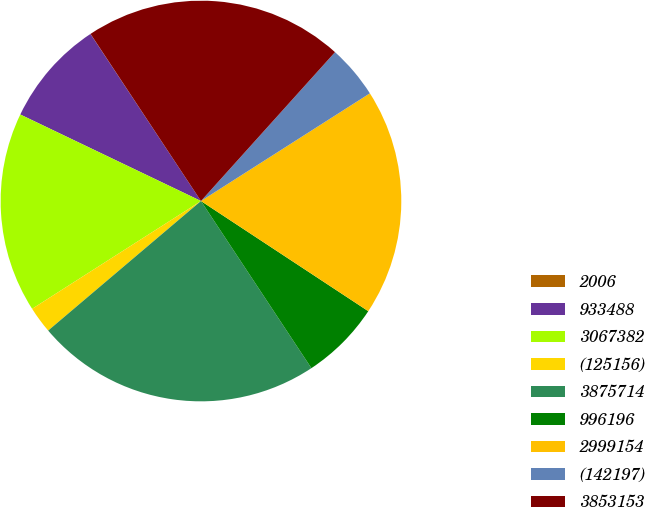Convert chart. <chart><loc_0><loc_0><loc_500><loc_500><pie_chart><fcel>2006<fcel>933488<fcel>3067382<fcel>(125156)<fcel>3875714<fcel>996196<fcel>2999154<fcel>(142197)<fcel>3853153<nl><fcel>0.01%<fcel>8.59%<fcel>16.15%<fcel>2.15%<fcel>23.1%<fcel>6.44%<fcel>18.3%<fcel>4.3%<fcel>20.96%<nl></chart> 